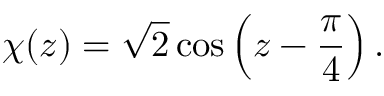<formula> <loc_0><loc_0><loc_500><loc_500>\chi ( z ) = \sqrt { 2 } \cos \left ( z - \frac { \pi } { 4 } \right ) .</formula> 